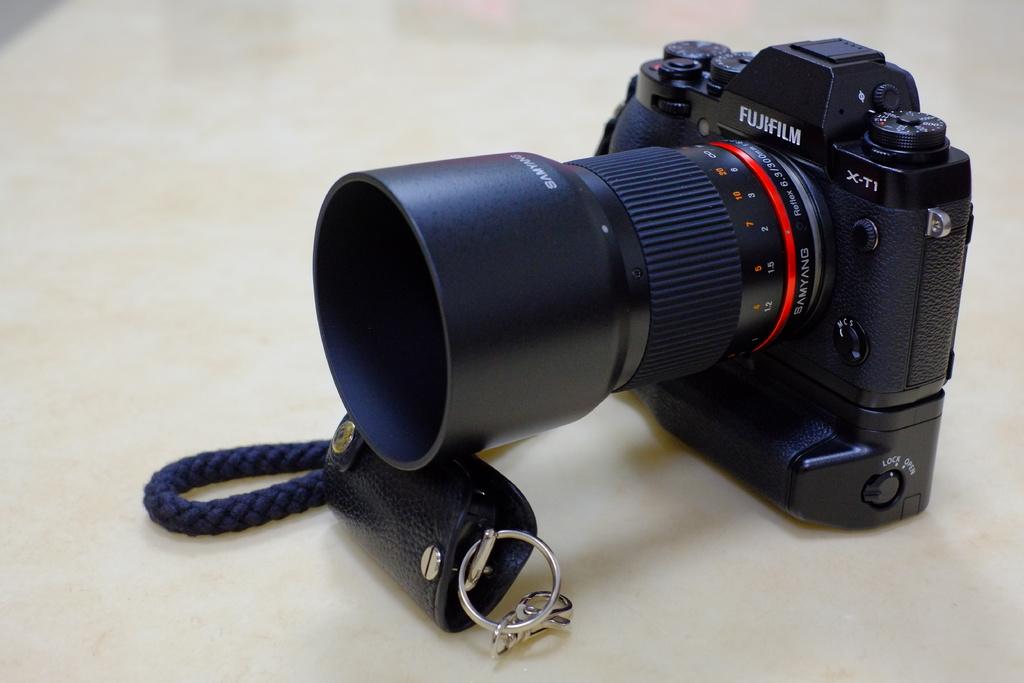What model is this camera that is displayed on the right corner?
Give a very brief answer. X-ti. 